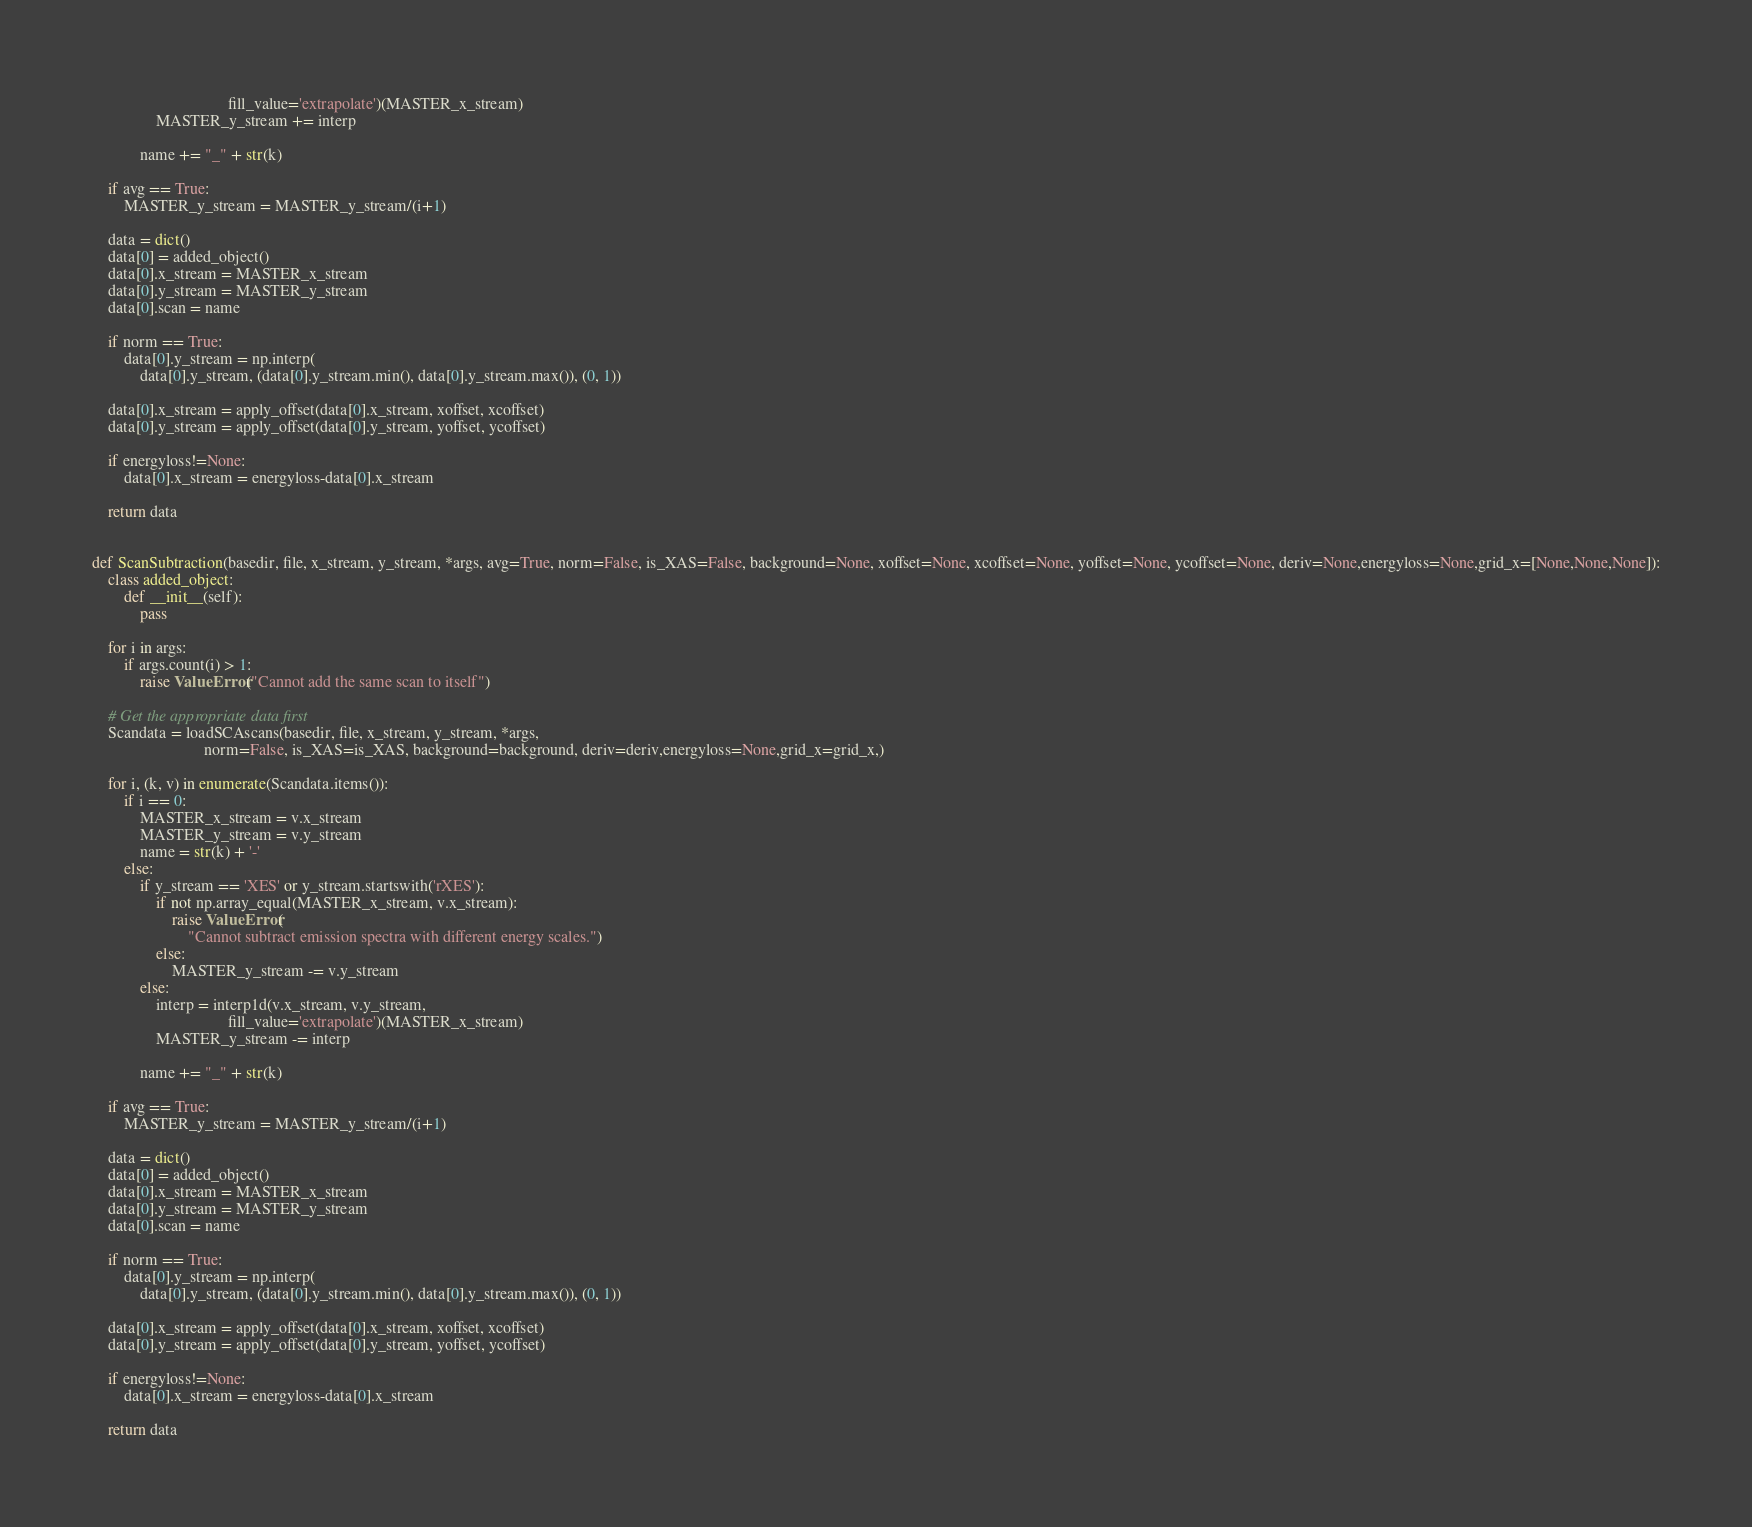<code> <loc_0><loc_0><loc_500><loc_500><_Python_>                                  fill_value='extrapolate')(MASTER_x_stream)
                MASTER_y_stream += interp

            name += "_" + str(k)

    if avg == True:
        MASTER_y_stream = MASTER_y_stream/(i+1)

    data = dict()
    data[0] = added_object()
    data[0].x_stream = MASTER_x_stream
    data[0].y_stream = MASTER_y_stream
    data[0].scan = name

    if norm == True:
        data[0].y_stream = np.interp(
            data[0].y_stream, (data[0].y_stream.min(), data[0].y_stream.max()), (0, 1))

    data[0].x_stream = apply_offset(data[0].x_stream, xoffset, xcoffset)
    data[0].y_stream = apply_offset(data[0].y_stream, yoffset, ycoffset)

    if energyloss!=None:
        data[0].x_stream = energyloss-data[0].x_stream

    return data


def ScanSubtraction(basedir, file, x_stream, y_stream, *args, avg=True, norm=False, is_XAS=False, background=None, xoffset=None, xcoffset=None, yoffset=None, ycoffset=None, deriv=None,energyloss=None,grid_x=[None,None,None]):
    class added_object:
        def __init__(self):
            pass

    for i in args:
        if args.count(i) > 1:
            raise ValueError("Cannot add the same scan to itself")

    # Get the appropriate data first
    Scandata = loadSCAscans(basedir, file, x_stream, y_stream, *args,
                            norm=False, is_XAS=is_XAS, background=background, deriv=deriv,energyloss=None,grid_x=grid_x,)

    for i, (k, v) in enumerate(Scandata.items()):
        if i == 0:
            MASTER_x_stream = v.x_stream
            MASTER_y_stream = v.y_stream
            name = str(k) + '-'
        else:
            if y_stream == 'XES' or y_stream.startswith('rXES'):
                if not np.array_equal(MASTER_x_stream, v.x_stream):
                    raise ValueError(
                        "Cannot subtract emission spectra with different energy scales.")
                else:
                    MASTER_y_stream -= v.y_stream
            else:
                interp = interp1d(v.x_stream, v.y_stream,
                                  fill_value='extrapolate')(MASTER_x_stream)
                MASTER_y_stream -= interp

            name += "_" + str(k)

    if avg == True:
        MASTER_y_stream = MASTER_y_stream/(i+1)

    data = dict()
    data[0] = added_object()
    data[0].x_stream = MASTER_x_stream
    data[0].y_stream = MASTER_y_stream
    data[0].scan = name

    if norm == True:
        data[0].y_stream = np.interp(
            data[0].y_stream, (data[0].y_stream.min(), data[0].y_stream.max()), (0, 1))

    data[0].x_stream = apply_offset(data[0].x_stream, xoffset, xcoffset)
    data[0].y_stream = apply_offset(data[0].y_stream, yoffset, ycoffset)

    if energyloss!=None:
        data[0].x_stream = energyloss-data[0].x_stream

    return data
</code> 